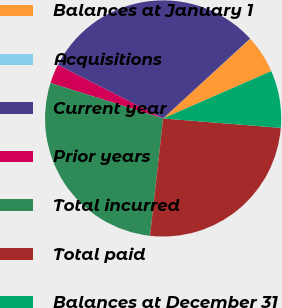Convert chart to OTSL. <chart><loc_0><loc_0><loc_500><loc_500><pie_chart><fcel>Balances at January 1<fcel>Acquisitions<fcel>Current year<fcel>Prior years<fcel>Total incurred<fcel>Total paid<fcel>Balances at December 31<nl><fcel>5.23%<fcel>0.03%<fcel>30.69%<fcel>2.63%<fcel>28.09%<fcel>25.49%<fcel>7.83%<nl></chart> 